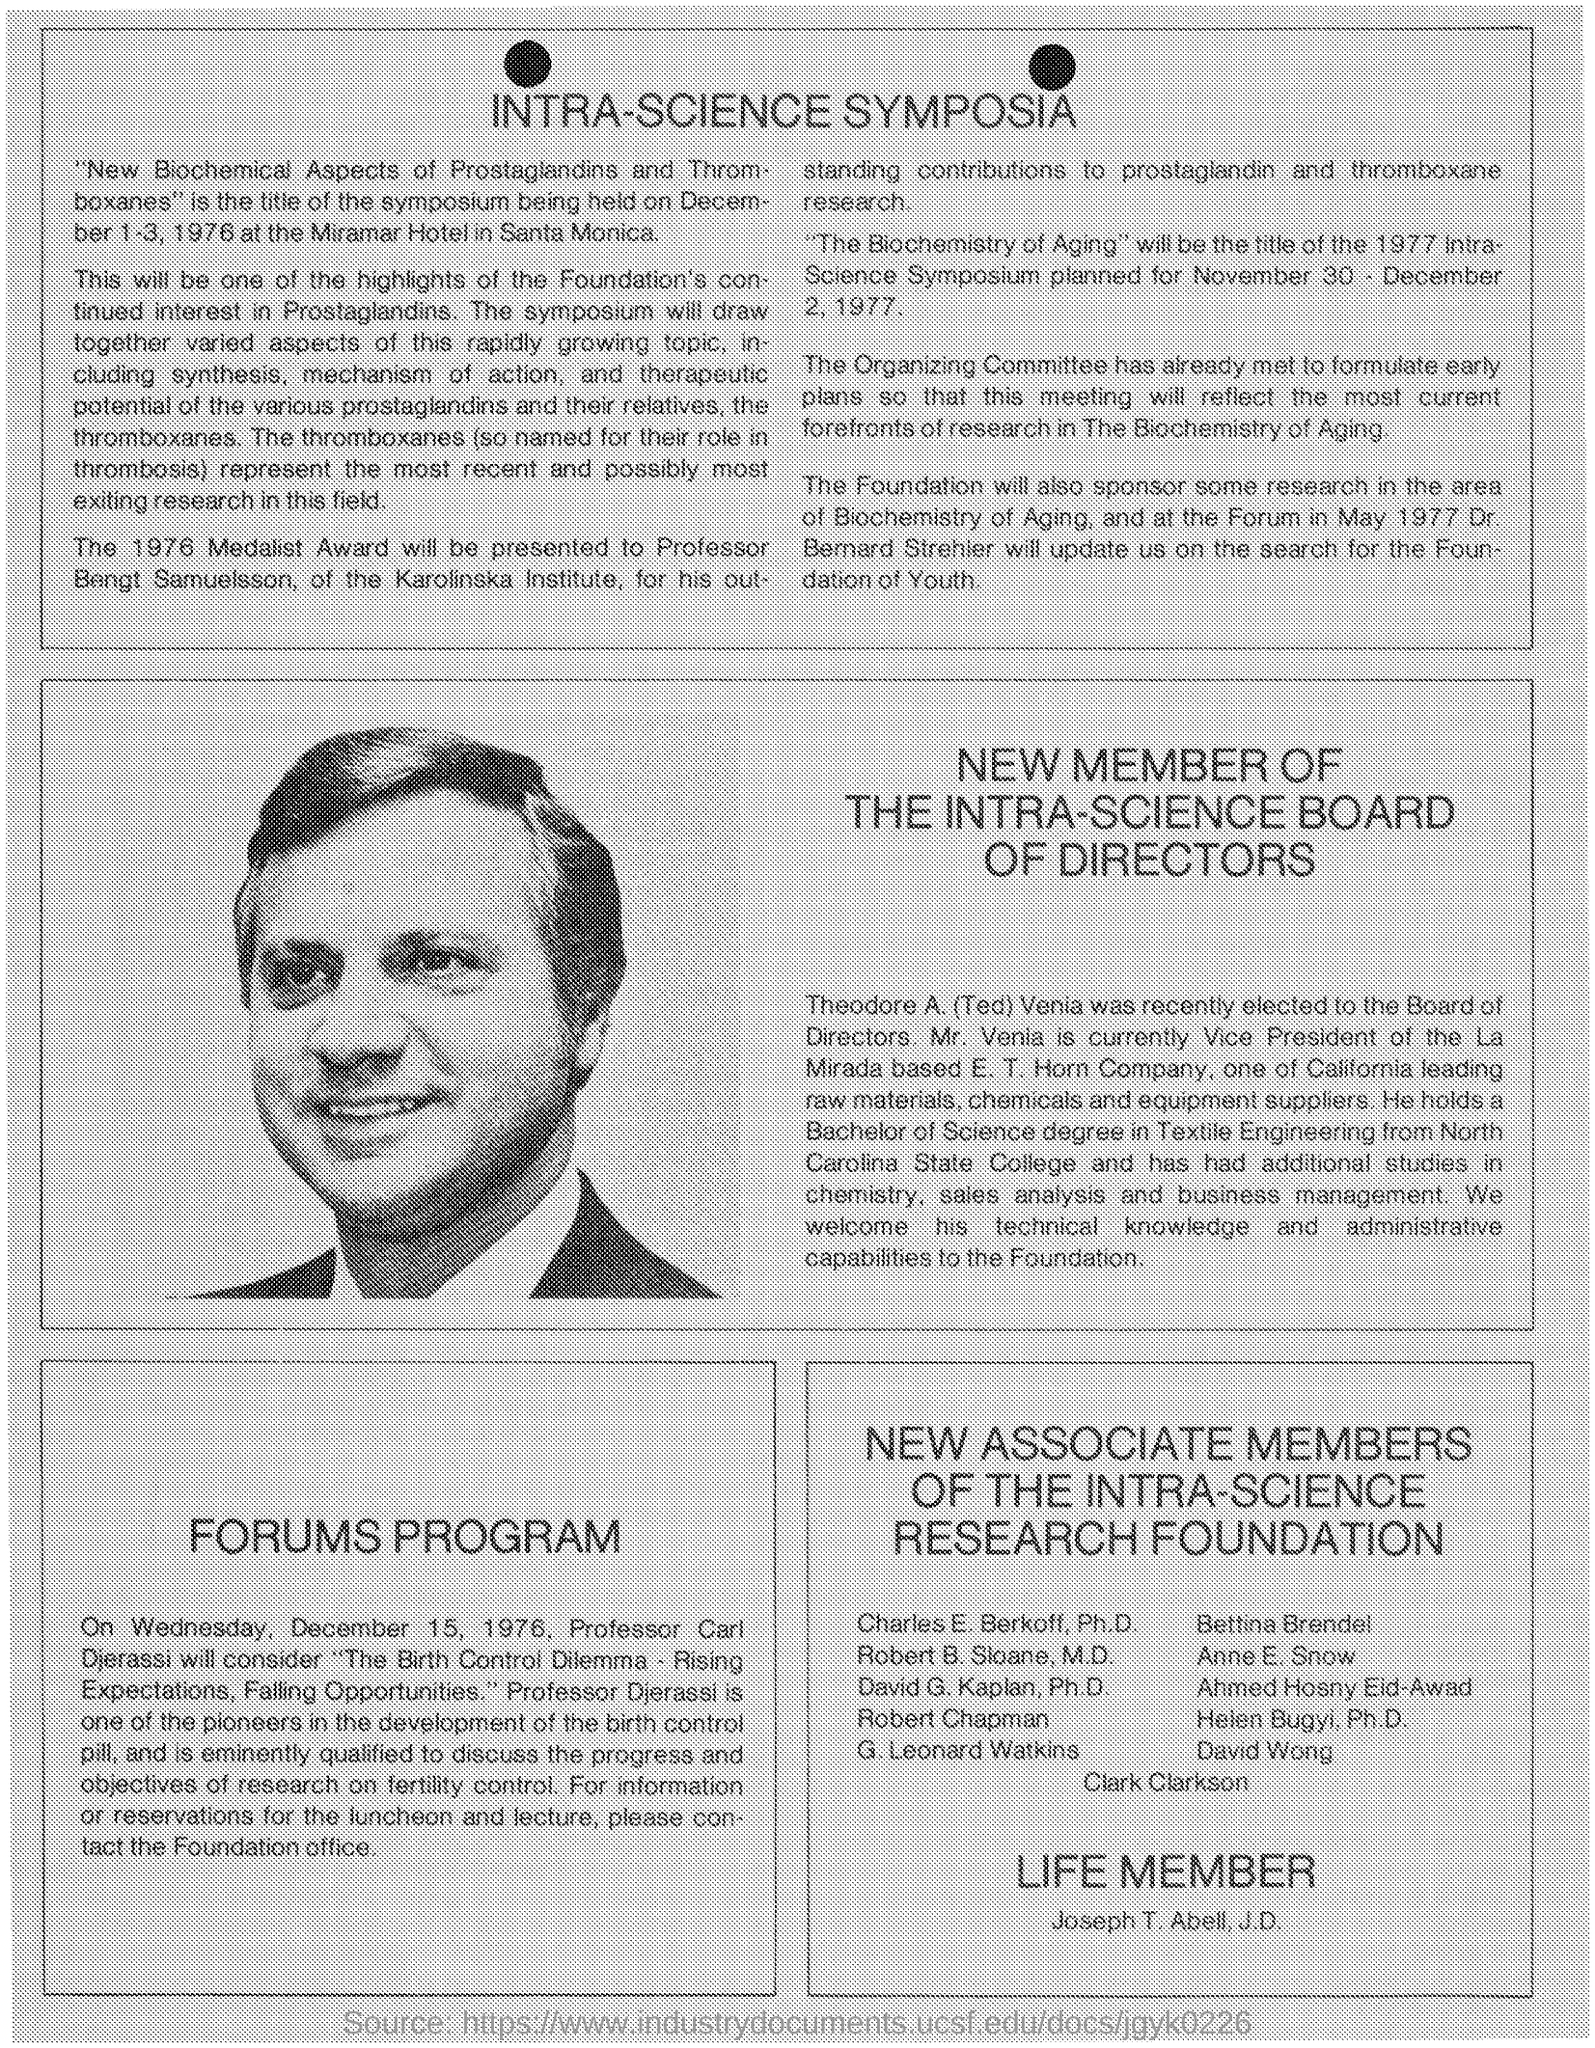When is the symposium on the title " New Biochemical Aspects of Prostagladins and Thromboxanes " is held ?
Make the answer very short. DECEMBER 1-3, 1976. Where is the symposium on the title " New Biochemical Aspects of Prostagladins and Thromboxanes " is held ?
Offer a very short reply. MIRAMAR HOTEL IN SANTA MONICA. Who got the "1976 Medalist Award " ?
Provide a short and direct response. PROFESSOR BENGT SAMUELSSON. In which institude, does Professor Bengt Samuelsson works ?
Ensure brevity in your answer.  KAROLINSKA INSTITUTE. What is the designation of 'Bengt Samuelsson' ?
Make the answer very short. PROFESSOR. Who is currently the vice president of the La Mirada?
Make the answer very short. MR. VENIA. 